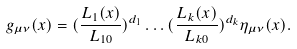<formula> <loc_0><loc_0><loc_500><loc_500>g _ { \mu \nu } ( x ) = ( \frac { L _ { 1 } ( x ) } { L _ { 1 0 } } ) ^ { d _ { 1 } } \dots ( \frac { L _ { k } ( x ) } { L _ { k 0 } } ) ^ { d _ { k } } \eta _ { \mu \nu } ( x ) .</formula> 